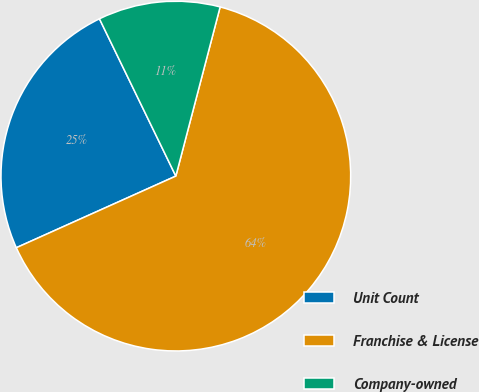Convert chart to OTSL. <chart><loc_0><loc_0><loc_500><loc_500><pie_chart><fcel>Unit Count<fcel>Franchise & License<fcel>Company-owned<nl><fcel>24.52%<fcel>64.2%<fcel>11.27%<nl></chart> 